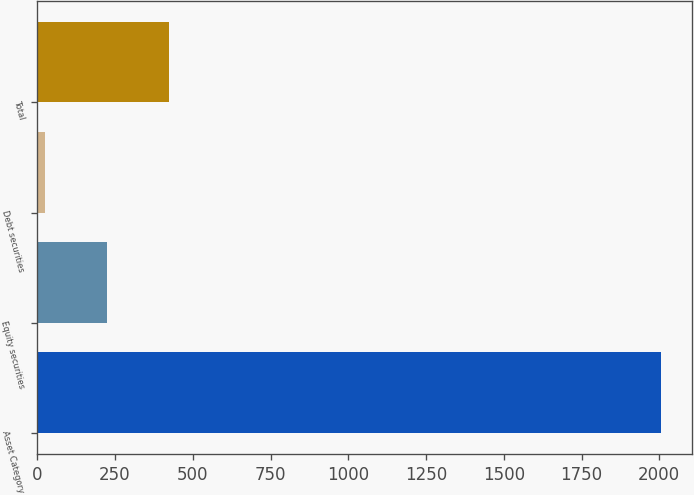<chart> <loc_0><loc_0><loc_500><loc_500><bar_chart><fcel>Asset Category<fcel>Equity securities<fcel>Debt securities<fcel>Total<nl><fcel>2006<fcel>224<fcel>26<fcel>422<nl></chart> 